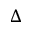<formula> <loc_0><loc_0><loc_500><loc_500>\Delta</formula> 